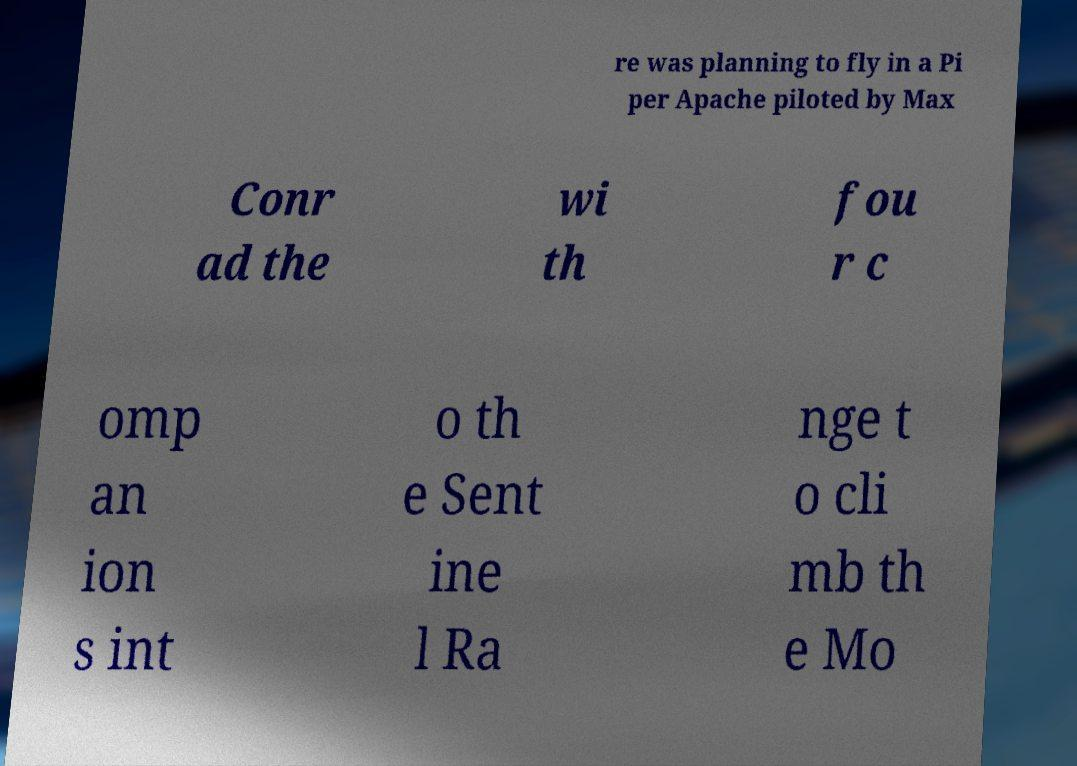Could you assist in decoding the text presented in this image and type it out clearly? re was planning to fly in a Pi per Apache piloted by Max Conr ad the wi th fou r c omp an ion s int o th e Sent ine l Ra nge t o cli mb th e Mo 